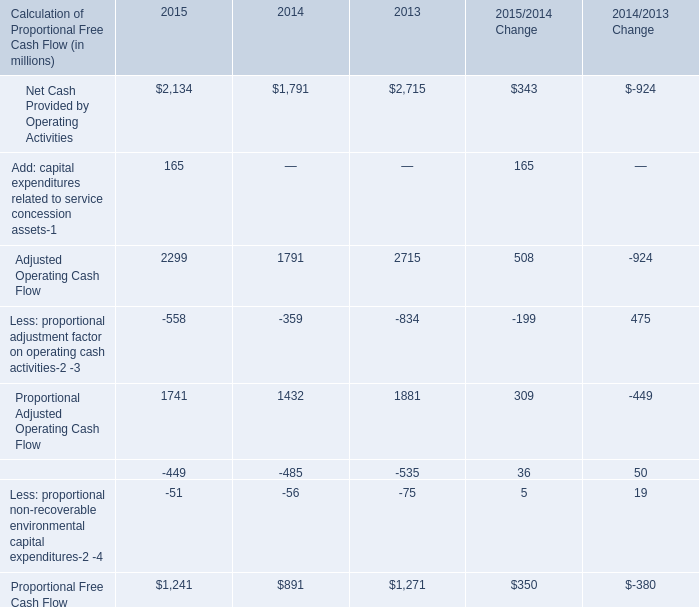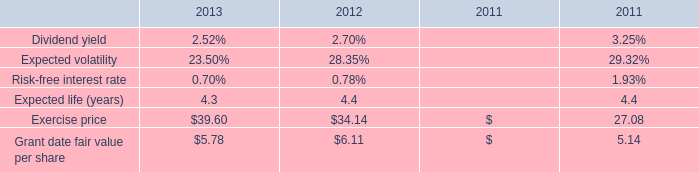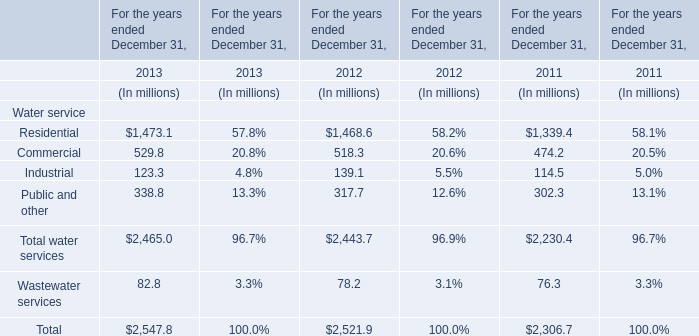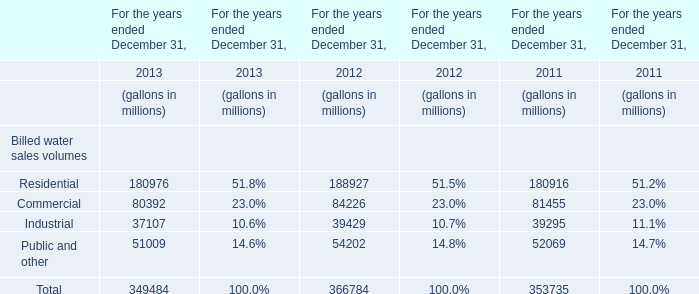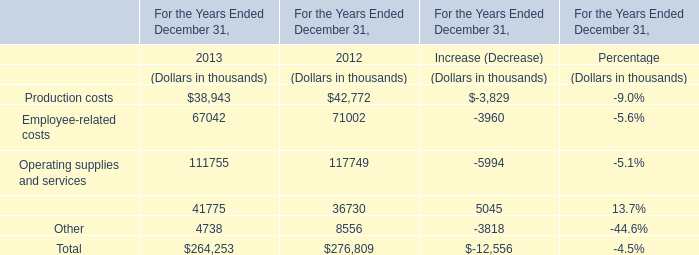What's the total amount of water services in 2013? (in dollars in millions) 
Answer: 24650. 